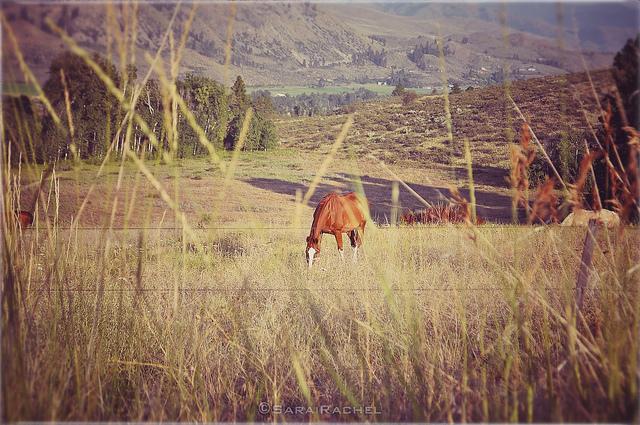Is it winter time in this photo?
Quick response, please. No. Is the horse eating?
Give a very brief answer. Yes. What are these animals eating?
Answer briefly. Grass. Is this a beautiful landscape?
Quick response, please. Yes. Is there a boat in this scene?
Short answer required. No. 